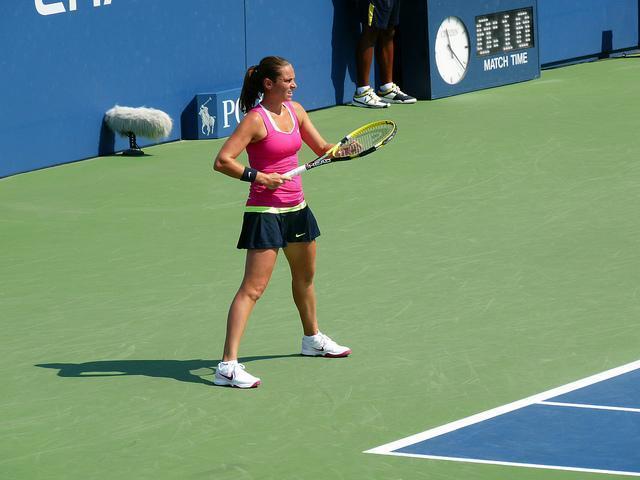How many seconds are on the clock?
Give a very brief answer. 10. How many people are in the photo?
Give a very brief answer. 2. 